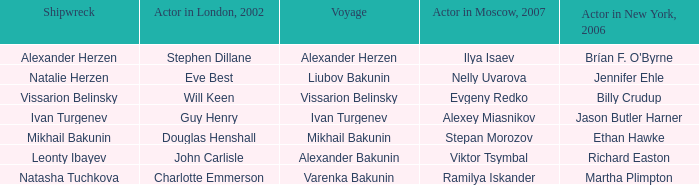Who was the actor in Moscow who did the part done by John Carlisle in London in 2002? Viktor Tsymbal. 